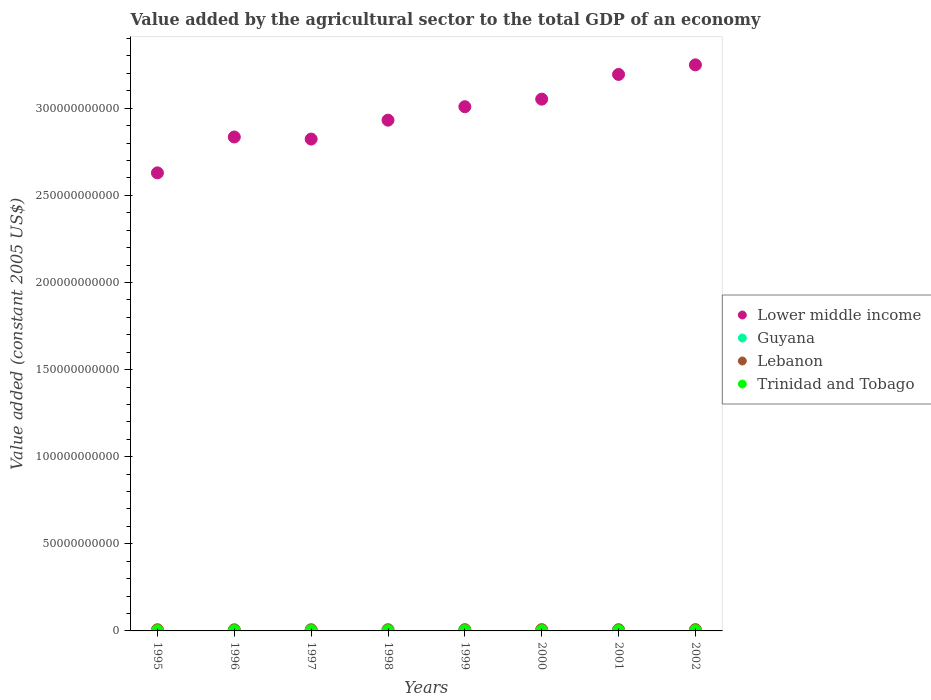How many different coloured dotlines are there?
Offer a very short reply. 4. What is the value added by the agricultural sector in Lower middle income in 1998?
Provide a succinct answer. 2.93e+11. Across all years, what is the maximum value added by the agricultural sector in Trinidad and Tobago?
Your response must be concise. 1.47e+08. Across all years, what is the minimum value added by the agricultural sector in Lower middle income?
Offer a very short reply. 2.63e+11. What is the total value added by the agricultural sector in Lebanon in the graph?
Your answer should be very brief. 5.63e+09. What is the difference between the value added by the agricultural sector in Lower middle income in 1997 and that in 2001?
Offer a very short reply. -3.71e+1. What is the difference between the value added by the agricultural sector in Guyana in 2002 and the value added by the agricultural sector in Trinidad and Tobago in 1996?
Make the answer very short. 1.49e+08. What is the average value added by the agricultural sector in Guyana per year?
Your response must be concise. 2.52e+08. In the year 1996, what is the difference between the value added by the agricultural sector in Lower middle income and value added by the agricultural sector in Trinidad and Tobago?
Provide a short and direct response. 2.83e+11. What is the ratio of the value added by the agricultural sector in Guyana in 1999 to that in 2001?
Offer a very short reply. 1.06. Is the difference between the value added by the agricultural sector in Lower middle income in 1997 and 1998 greater than the difference between the value added by the agricultural sector in Trinidad and Tobago in 1997 and 1998?
Offer a terse response. No. What is the difference between the highest and the second highest value added by the agricultural sector in Guyana?
Keep it short and to the point. 7.50e+06. What is the difference between the highest and the lowest value added by the agricultural sector in Guyana?
Give a very brief answer. 4.24e+07. Does the value added by the agricultural sector in Guyana monotonically increase over the years?
Make the answer very short. No. Is the value added by the agricultural sector in Lower middle income strictly greater than the value added by the agricultural sector in Trinidad and Tobago over the years?
Give a very brief answer. Yes. What is the difference between two consecutive major ticks on the Y-axis?
Your answer should be compact. 5.00e+1. Does the graph contain any zero values?
Your response must be concise. No. Does the graph contain grids?
Your answer should be very brief. No. What is the title of the graph?
Your response must be concise. Value added by the agricultural sector to the total GDP of an economy. What is the label or title of the X-axis?
Provide a succinct answer. Years. What is the label or title of the Y-axis?
Offer a terse response. Value added (constant 2005 US$). What is the Value added (constant 2005 US$) of Lower middle income in 1995?
Give a very brief answer. 2.63e+11. What is the Value added (constant 2005 US$) of Guyana in 1995?
Offer a very short reply. 2.30e+08. What is the Value added (constant 2005 US$) of Lebanon in 1995?
Offer a terse response. 6.78e+08. What is the Value added (constant 2005 US$) in Trinidad and Tobago in 1995?
Provide a succinct answer. 1.08e+08. What is the Value added (constant 2005 US$) of Lower middle income in 1996?
Provide a short and direct response. 2.83e+11. What is the Value added (constant 2005 US$) in Guyana in 1996?
Offer a very short reply. 2.47e+08. What is the Value added (constant 2005 US$) of Lebanon in 1996?
Ensure brevity in your answer.  6.49e+08. What is the Value added (constant 2005 US$) of Trinidad and Tobago in 1996?
Offer a very short reply. 1.17e+08. What is the Value added (constant 2005 US$) in Lower middle income in 1997?
Give a very brief answer. 2.82e+11. What is the Value added (constant 2005 US$) in Guyana in 1997?
Offer a terse response. 2.57e+08. What is the Value added (constant 2005 US$) of Lebanon in 1997?
Make the answer very short. 6.87e+08. What is the Value added (constant 2005 US$) of Trinidad and Tobago in 1997?
Give a very brief answer. 1.20e+08. What is the Value added (constant 2005 US$) in Lower middle income in 1998?
Provide a short and direct response. 2.93e+11. What is the Value added (constant 2005 US$) of Guyana in 1998?
Offer a very short reply. 2.40e+08. What is the Value added (constant 2005 US$) in Lebanon in 1998?
Your answer should be very brief. 6.95e+08. What is the Value added (constant 2005 US$) in Trinidad and Tobago in 1998?
Offer a very short reply. 1.09e+08. What is the Value added (constant 2005 US$) of Lower middle income in 1999?
Your answer should be very brief. 3.01e+11. What is the Value added (constant 2005 US$) in Guyana in 1999?
Offer a terse response. 2.73e+08. What is the Value added (constant 2005 US$) of Lebanon in 1999?
Your answer should be compact. 7.24e+08. What is the Value added (constant 2005 US$) in Trinidad and Tobago in 1999?
Give a very brief answer. 1.27e+08. What is the Value added (constant 2005 US$) of Lower middle income in 2000?
Offer a terse response. 3.05e+11. What is the Value added (constant 2005 US$) of Guyana in 2000?
Your answer should be compact. 2.48e+08. What is the Value added (constant 2005 US$) of Lebanon in 2000?
Your answer should be compact. 7.39e+08. What is the Value added (constant 2005 US$) of Trinidad and Tobago in 2000?
Your response must be concise. 1.24e+08. What is the Value added (constant 2005 US$) in Lower middle income in 2001?
Give a very brief answer. 3.19e+11. What is the Value added (constant 2005 US$) in Guyana in 2001?
Keep it short and to the point. 2.56e+08. What is the Value added (constant 2005 US$) in Lebanon in 2001?
Make the answer very short. 7.18e+08. What is the Value added (constant 2005 US$) of Trinidad and Tobago in 2001?
Your answer should be compact. 1.35e+08. What is the Value added (constant 2005 US$) in Lower middle income in 2002?
Make the answer very short. 3.25e+11. What is the Value added (constant 2005 US$) in Guyana in 2002?
Provide a succinct answer. 2.65e+08. What is the Value added (constant 2005 US$) of Lebanon in 2002?
Your answer should be compact. 7.38e+08. What is the Value added (constant 2005 US$) in Trinidad and Tobago in 2002?
Your response must be concise. 1.47e+08. Across all years, what is the maximum Value added (constant 2005 US$) in Lower middle income?
Give a very brief answer. 3.25e+11. Across all years, what is the maximum Value added (constant 2005 US$) of Guyana?
Your answer should be very brief. 2.73e+08. Across all years, what is the maximum Value added (constant 2005 US$) of Lebanon?
Give a very brief answer. 7.39e+08. Across all years, what is the maximum Value added (constant 2005 US$) of Trinidad and Tobago?
Ensure brevity in your answer.  1.47e+08. Across all years, what is the minimum Value added (constant 2005 US$) in Lower middle income?
Your response must be concise. 2.63e+11. Across all years, what is the minimum Value added (constant 2005 US$) in Guyana?
Ensure brevity in your answer.  2.30e+08. Across all years, what is the minimum Value added (constant 2005 US$) in Lebanon?
Your answer should be compact. 6.49e+08. Across all years, what is the minimum Value added (constant 2005 US$) of Trinidad and Tobago?
Provide a short and direct response. 1.08e+08. What is the total Value added (constant 2005 US$) of Lower middle income in the graph?
Offer a terse response. 2.37e+12. What is the total Value added (constant 2005 US$) in Guyana in the graph?
Your answer should be compact. 2.02e+09. What is the total Value added (constant 2005 US$) of Lebanon in the graph?
Make the answer very short. 5.63e+09. What is the total Value added (constant 2005 US$) of Trinidad and Tobago in the graph?
Your response must be concise. 9.87e+08. What is the difference between the Value added (constant 2005 US$) in Lower middle income in 1995 and that in 1996?
Ensure brevity in your answer.  -2.06e+1. What is the difference between the Value added (constant 2005 US$) in Guyana in 1995 and that in 1996?
Offer a terse response. -1.70e+07. What is the difference between the Value added (constant 2005 US$) in Lebanon in 1995 and that in 1996?
Give a very brief answer. 2.94e+07. What is the difference between the Value added (constant 2005 US$) in Trinidad and Tobago in 1995 and that in 1996?
Make the answer very short. -8.18e+06. What is the difference between the Value added (constant 2005 US$) of Lower middle income in 1995 and that in 1997?
Keep it short and to the point. -1.94e+1. What is the difference between the Value added (constant 2005 US$) of Guyana in 1995 and that in 1997?
Your answer should be compact. -2.67e+07. What is the difference between the Value added (constant 2005 US$) of Lebanon in 1995 and that in 1997?
Offer a very short reply. -9.33e+06. What is the difference between the Value added (constant 2005 US$) in Trinidad and Tobago in 1995 and that in 1997?
Your answer should be compact. -1.18e+07. What is the difference between the Value added (constant 2005 US$) in Lower middle income in 1995 and that in 1998?
Give a very brief answer. -3.03e+1. What is the difference between the Value added (constant 2005 US$) of Guyana in 1995 and that in 1998?
Make the answer very short. -1.01e+07. What is the difference between the Value added (constant 2005 US$) of Lebanon in 1995 and that in 1998?
Give a very brief answer. -1.69e+07. What is the difference between the Value added (constant 2005 US$) in Trinidad and Tobago in 1995 and that in 1998?
Make the answer very short. -5.92e+05. What is the difference between the Value added (constant 2005 US$) of Lower middle income in 1995 and that in 1999?
Your answer should be compact. -3.80e+1. What is the difference between the Value added (constant 2005 US$) of Guyana in 1995 and that in 1999?
Offer a very short reply. -4.24e+07. What is the difference between the Value added (constant 2005 US$) of Lebanon in 1995 and that in 1999?
Your response must be concise. -4.61e+07. What is the difference between the Value added (constant 2005 US$) of Trinidad and Tobago in 1995 and that in 1999?
Offer a terse response. -1.88e+07. What is the difference between the Value added (constant 2005 US$) in Lower middle income in 1995 and that in 2000?
Your response must be concise. -4.23e+1. What is the difference between the Value added (constant 2005 US$) of Guyana in 1995 and that in 2000?
Ensure brevity in your answer.  -1.75e+07. What is the difference between the Value added (constant 2005 US$) in Lebanon in 1995 and that in 2000?
Provide a short and direct response. -6.13e+07. What is the difference between the Value added (constant 2005 US$) in Trinidad and Tobago in 1995 and that in 2000?
Your answer should be very brief. -1.57e+07. What is the difference between the Value added (constant 2005 US$) in Lower middle income in 1995 and that in 2001?
Ensure brevity in your answer.  -5.65e+1. What is the difference between the Value added (constant 2005 US$) in Guyana in 1995 and that in 2001?
Offer a terse response. -2.59e+07. What is the difference between the Value added (constant 2005 US$) in Lebanon in 1995 and that in 2001?
Offer a terse response. -3.98e+07. What is the difference between the Value added (constant 2005 US$) in Trinidad and Tobago in 1995 and that in 2001?
Ensure brevity in your answer.  -2.65e+07. What is the difference between the Value added (constant 2005 US$) of Lower middle income in 1995 and that in 2002?
Give a very brief answer. -6.20e+1. What is the difference between the Value added (constant 2005 US$) of Guyana in 1995 and that in 2002?
Provide a short and direct response. -3.49e+07. What is the difference between the Value added (constant 2005 US$) in Lebanon in 1995 and that in 2002?
Provide a succinct answer. -5.99e+07. What is the difference between the Value added (constant 2005 US$) of Trinidad and Tobago in 1995 and that in 2002?
Provide a succinct answer. -3.83e+07. What is the difference between the Value added (constant 2005 US$) in Lower middle income in 1996 and that in 1997?
Make the answer very short. 1.19e+09. What is the difference between the Value added (constant 2005 US$) in Guyana in 1996 and that in 1997?
Provide a short and direct response. -9.79e+06. What is the difference between the Value added (constant 2005 US$) in Lebanon in 1996 and that in 1997?
Your response must be concise. -3.87e+07. What is the difference between the Value added (constant 2005 US$) of Trinidad and Tobago in 1996 and that in 1997?
Provide a short and direct response. -3.61e+06. What is the difference between the Value added (constant 2005 US$) of Lower middle income in 1996 and that in 1998?
Ensure brevity in your answer.  -9.66e+09. What is the difference between the Value added (constant 2005 US$) of Guyana in 1996 and that in 1998?
Make the answer very short. 6.85e+06. What is the difference between the Value added (constant 2005 US$) in Lebanon in 1996 and that in 1998?
Provide a succinct answer. -4.63e+07. What is the difference between the Value added (constant 2005 US$) in Trinidad and Tobago in 1996 and that in 1998?
Your response must be concise. 7.58e+06. What is the difference between the Value added (constant 2005 US$) of Lower middle income in 1996 and that in 1999?
Keep it short and to the point. -1.74e+1. What is the difference between the Value added (constant 2005 US$) of Guyana in 1996 and that in 1999?
Your response must be concise. -2.54e+07. What is the difference between the Value added (constant 2005 US$) in Lebanon in 1996 and that in 1999?
Your response must be concise. -7.54e+07. What is the difference between the Value added (constant 2005 US$) in Trinidad and Tobago in 1996 and that in 1999?
Your answer should be compact. -1.06e+07. What is the difference between the Value added (constant 2005 US$) in Lower middle income in 1996 and that in 2000?
Offer a terse response. -2.17e+1. What is the difference between the Value added (constant 2005 US$) of Guyana in 1996 and that in 2000?
Your answer should be very brief. -4.89e+05. What is the difference between the Value added (constant 2005 US$) of Lebanon in 1996 and that in 2000?
Offer a terse response. -9.06e+07. What is the difference between the Value added (constant 2005 US$) in Trinidad and Tobago in 1996 and that in 2000?
Ensure brevity in your answer.  -7.57e+06. What is the difference between the Value added (constant 2005 US$) of Lower middle income in 1996 and that in 2001?
Keep it short and to the point. -3.59e+1. What is the difference between the Value added (constant 2005 US$) of Guyana in 1996 and that in 2001?
Keep it short and to the point. -8.97e+06. What is the difference between the Value added (constant 2005 US$) in Lebanon in 1996 and that in 2001?
Your answer should be compact. -6.92e+07. What is the difference between the Value added (constant 2005 US$) in Trinidad and Tobago in 1996 and that in 2001?
Ensure brevity in your answer.  -1.83e+07. What is the difference between the Value added (constant 2005 US$) in Lower middle income in 1996 and that in 2002?
Offer a very short reply. -4.14e+1. What is the difference between the Value added (constant 2005 US$) of Guyana in 1996 and that in 2002?
Ensure brevity in your answer.  -1.79e+07. What is the difference between the Value added (constant 2005 US$) of Lebanon in 1996 and that in 2002?
Offer a terse response. -8.93e+07. What is the difference between the Value added (constant 2005 US$) of Trinidad and Tobago in 1996 and that in 2002?
Offer a terse response. -3.01e+07. What is the difference between the Value added (constant 2005 US$) in Lower middle income in 1997 and that in 1998?
Your answer should be very brief. -1.08e+1. What is the difference between the Value added (constant 2005 US$) of Guyana in 1997 and that in 1998?
Provide a short and direct response. 1.66e+07. What is the difference between the Value added (constant 2005 US$) in Lebanon in 1997 and that in 1998?
Offer a very short reply. -7.56e+06. What is the difference between the Value added (constant 2005 US$) of Trinidad and Tobago in 1997 and that in 1998?
Provide a succinct answer. 1.12e+07. What is the difference between the Value added (constant 2005 US$) in Lower middle income in 1997 and that in 1999?
Make the answer very short. -1.86e+1. What is the difference between the Value added (constant 2005 US$) in Guyana in 1997 and that in 1999?
Your answer should be compact. -1.57e+07. What is the difference between the Value added (constant 2005 US$) in Lebanon in 1997 and that in 1999?
Make the answer very short. -3.68e+07. What is the difference between the Value added (constant 2005 US$) in Trinidad and Tobago in 1997 and that in 1999?
Make the answer very short. -6.97e+06. What is the difference between the Value added (constant 2005 US$) of Lower middle income in 1997 and that in 2000?
Your answer should be compact. -2.29e+1. What is the difference between the Value added (constant 2005 US$) in Guyana in 1997 and that in 2000?
Provide a succinct answer. 9.30e+06. What is the difference between the Value added (constant 2005 US$) of Lebanon in 1997 and that in 2000?
Offer a terse response. -5.20e+07. What is the difference between the Value added (constant 2005 US$) of Trinidad and Tobago in 1997 and that in 2000?
Ensure brevity in your answer.  -3.96e+06. What is the difference between the Value added (constant 2005 US$) in Lower middle income in 1997 and that in 2001?
Offer a terse response. -3.71e+1. What is the difference between the Value added (constant 2005 US$) of Guyana in 1997 and that in 2001?
Your response must be concise. 8.15e+05. What is the difference between the Value added (constant 2005 US$) in Lebanon in 1997 and that in 2001?
Offer a very short reply. -3.05e+07. What is the difference between the Value added (constant 2005 US$) of Trinidad and Tobago in 1997 and that in 2001?
Ensure brevity in your answer.  -1.47e+07. What is the difference between the Value added (constant 2005 US$) in Lower middle income in 1997 and that in 2002?
Make the answer very short. -4.26e+1. What is the difference between the Value added (constant 2005 US$) of Guyana in 1997 and that in 2002?
Offer a very short reply. -8.15e+06. What is the difference between the Value added (constant 2005 US$) of Lebanon in 1997 and that in 2002?
Your response must be concise. -5.06e+07. What is the difference between the Value added (constant 2005 US$) in Trinidad and Tobago in 1997 and that in 2002?
Your answer should be compact. -2.65e+07. What is the difference between the Value added (constant 2005 US$) of Lower middle income in 1998 and that in 1999?
Ensure brevity in your answer.  -7.72e+09. What is the difference between the Value added (constant 2005 US$) of Guyana in 1998 and that in 1999?
Ensure brevity in your answer.  -3.23e+07. What is the difference between the Value added (constant 2005 US$) in Lebanon in 1998 and that in 1999?
Your answer should be compact. -2.92e+07. What is the difference between the Value added (constant 2005 US$) in Trinidad and Tobago in 1998 and that in 1999?
Provide a short and direct response. -1.82e+07. What is the difference between the Value added (constant 2005 US$) in Lower middle income in 1998 and that in 2000?
Provide a succinct answer. -1.21e+1. What is the difference between the Value added (constant 2005 US$) in Guyana in 1998 and that in 2000?
Provide a succinct answer. -7.34e+06. What is the difference between the Value added (constant 2005 US$) in Lebanon in 1998 and that in 2000?
Keep it short and to the point. -4.44e+07. What is the difference between the Value added (constant 2005 US$) of Trinidad and Tobago in 1998 and that in 2000?
Give a very brief answer. -1.52e+07. What is the difference between the Value added (constant 2005 US$) in Lower middle income in 1998 and that in 2001?
Your answer should be compact. -2.62e+1. What is the difference between the Value added (constant 2005 US$) in Guyana in 1998 and that in 2001?
Give a very brief answer. -1.58e+07. What is the difference between the Value added (constant 2005 US$) of Lebanon in 1998 and that in 2001?
Your answer should be compact. -2.30e+07. What is the difference between the Value added (constant 2005 US$) in Trinidad and Tobago in 1998 and that in 2001?
Offer a terse response. -2.59e+07. What is the difference between the Value added (constant 2005 US$) of Lower middle income in 1998 and that in 2002?
Make the answer very short. -3.17e+1. What is the difference between the Value added (constant 2005 US$) of Guyana in 1998 and that in 2002?
Provide a succinct answer. -2.48e+07. What is the difference between the Value added (constant 2005 US$) of Lebanon in 1998 and that in 2002?
Your answer should be very brief. -4.31e+07. What is the difference between the Value added (constant 2005 US$) in Trinidad and Tobago in 1998 and that in 2002?
Make the answer very short. -3.77e+07. What is the difference between the Value added (constant 2005 US$) in Lower middle income in 1999 and that in 2000?
Provide a succinct answer. -4.34e+09. What is the difference between the Value added (constant 2005 US$) of Guyana in 1999 and that in 2000?
Offer a terse response. 2.50e+07. What is the difference between the Value added (constant 2005 US$) of Lebanon in 1999 and that in 2000?
Make the answer very short. -1.52e+07. What is the difference between the Value added (constant 2005 US$) of Trinidad and Tobago in 1999 and that in 2000?
Your answer should be very brief. 3.01e+06. What is the difference between the Value added (constant 2005 US$) of Lower middle income in 1999 and that in 2001?
Ensure brevity in your answer.  -1.85e+1. What is the difference between the Value added (constant 2005 US$) of Guyana in 1999 and that in 2001?
Your response must be concise. 1.65e+07. What is the difference between the Value added (constant 2005 US$) in Lebanon in 1999 and that in 2001?
Provide a short and direct response. 6.23e+06. What is the difference between the Value added (constant 2005 US$) in Trinidad and Tobago in 1999 and that in 2001?
Your answer should be compact. -7.77e+06. What is the difference between the Value added (constant 2005 US$) in Lower middle income in 1999 and that in 2002?
Your answer should be compact. -2.40e+1. What is the difference between the Value added (constant 2005 US$) in Guyana in 1999 and that in 2002?
Give a very brief answer. 7.50e+06. What is the difference between the Value added (constant 2005 US$) of Lebanon in 1999 and that in 2002?
Provide a succinct answer. -1.39e+07. What is the difference between the Value added (constant 2005 US$) of Trinidad and Tobago in 1999 and that in 2002?
Ensure brevity in your answer.  -1.95e+07. What is the difference between the Value added (constant 2005 US$) of Lower middle income in 2000 and that in 2001?
Provide a succinct answer. -1.42e+1. What is the difference between the Value added (constant 2005 US$) of Guyana in 2000 and that in 2001?
Make the answer very short. -8.48e+06. What is the difference between the Value added (constant 2005 US$) of Lebanon in 2000 and that in 2001?
Your answer should be very brief. 2.14e+07. What is the difference between the Value added (constant 2005 US$) in Trinidad and Tobago in 2000 and that in 2001?
Provide a succinct answer. -1.08e+07. What is the difference between the Value added (constant 2005 US$) in Lower middle income in 2000 and that in 2002?
Offer a very short reply. -1.97e+1. What is the difference between the Value added (constant 2005 US$) of Guyana in 2000 and that in 2002?
Your response must be concise. -1.75e+07. What is the difference between the Value added (constant 2005 US$) in Lebanon in 2000 and that in 2002?
Your response must be concise. 1.34e+06. What is the difference between the Value added (constant 2005 US$) of Trinidad and Tobago in 2000 and that in 2002?
Provide a succinct answer. -2.25e+07. What is the difference between the Value added (constant 2005 US$) of Lower middle income in 2001 and that in 2002?
Ensure brevity in your answer.  -5.49e+09. What is the difference between the Value added (constant 2005 US$) of Guyana in 2001 and that in 2002?
Provide a short and direct response. -8.97e+06. What is the difference between the Value added (constant 2005 US$) of Lebanon in 2001 and that in 2002?
Provide a short and direct response. -2.01e+07. What is the difference between the Value added (constant 2005 US$) of Trinidad and Tobago in 2001 and that in 2002?
Your answer should be compact. -1.18e+07. What is the difference between the Value added (constant 2005 US$) in Lower middle income in 1995 and the Value added (constant 2005 US$) in Guyana in 1996?
Ensure brevity in your answer.  2.63e+11. What is the difference between the Value added (constant 2005 US$) in Lower middle income in 1995 and the Value added (constant 2005 US$) in Lebanon in 1996?
Offer a terse response. 2.62e+11. What is the difference between the Value added (constant 2005 US$) of Lower middle income in 1995 and the Value added (constant 2005 US$) of Trinidad and Tobago in 1996?
Make the answer very short. 2.63e+11. What is the difference between the Value added (constant 2005 US$) of Guyana in 1995 and the Value added (constant 2005 US$) of Lebanon in 1996?
Ensure brevity in your answer.  -4.18e+08. What is the difference between the Value added (constant 2005 US$) in Guyana in 1995 and the Value added (constant 2005 US$) in Trinidad and Tobago in 1996?
Keep it short and to the point. 1.14e+08. What is the difference between the Value added (constant 2005 US$) of Lebanon in 1995 and the Value added (constant 2005 US$) of Trinidad and Tobago in 1996?
Offer a very short reply. 5.61e+08. What is the difference between the Value added (constant 2005 US$) in Lower middle income in 1995 and the Value added (constant 2005 US$) in Guyana in 1997?
Your response must be concise. 2.63e+11. What is the difference between the Value added (constant 2005 US$) in Lower middle income in 1995 and the Value added (constant 2005 US$) in Lebanon in 1997?
Provide a succinct answer. 2.62e+11. What is the difference between the Value added (constant 2005 US$) in Lower middle income in 1995 and the Value added (constant 2005 US$) in Trinidad and Tobago in 1997?
Provide a succinct answer. 2.63e+11. What is the difference between the Value added (constant 2005 US$) of Guyana in 1995 and the Value added (constant 2005 US$) of Lebanon in 1997?
Provide a succinct answer. -4.57e+08. What is the difference between the Value added (constant 2005 US$) in Guyana in 1995 and the Value added (constant 2005 US$) in Trinidad and Tobago in 1997?
Your answer should be very brief. 1.10e+08. What is the difference between the Value added (constant 2005 US$) in Lebanon in 1995 and the Value added (constant 2005 US$) in Trinidad and Tobago in 1997?
Ensure brevity in your answer.  5.58e+08. What is the difference between the Value added (constant 2005 US$) in Lower middle income in 1995 and the Value added (constant 2005 US$) in Guyana in 1998?
Your answer should be compact. 2.63e+11. What is the difference between the Value added (constant 2005 US$) of Lower middle income in 1995 and the Value added (constant 2005 US$) of Lebanon in 1998?
Ensure brevity in your answer.  2.62e+11. What is the difference between the Value added (constant 2005 US$) in Lower middle income in 1995 and the Value added (constant 2005 US$) in Trinidad and Tobago in 1998?
Your answer should be compact. 2.63e+11. What is the difference between the Value added (constant 2005 US$) of Guyana in 1995 and the Value added (constant 2005 US$) of Lebanon in 1998?
Your response must be concise. -4.65e+08. What is the difference between the Value added (constant 2005 US$) of Guyana in 1995 and the Value added (constant 2005 US$) of Trinidad and Tobago in 1998?
Provide a short and direct response. 1.21e+08. What is the difference between the Value added (constant 2005 US$) in Lebanon in 1995 and the Value added (constant 2005 US$) in Trinidad and Tobago in 1998?
Make the answer very short. 5.69e+08. What is the difference between the Value added (constant 2005 US$) of Lower middle income in 1995 and the Value added (constant 2005 US$) of Guyana in 1999?
Provide a succinct answer. 2.63e+11. What is the difference between the Value added (constant 2005 US$) of Lower middle income in 1995 and the Value added (constant 2005 US$) of Lebanon in 1999?
Give a very brief answer. 2.62e+11. What is the difference between the Value added (constant 2005 US$) of Lower middle income in 1995 and the Value added (constant 2005 US$) of Trinidad and Tobago in 1999?
Ensure brevity in your answer.  2.63e+11. What is the difference between the Value added (constant 2005 US$) in Guyana in 1995 and the Value added (constant 2005 US$) in Lebanon in 1999?
Your answer should be very brief. -4.94e+08. What is the difference between the Value added (constant 2005 US$) of Guyana in 1995 and the Value added (constant 2005 US$) of Trinidad and Tobago in 1999?
Offer a terse response. 1.03e+08. What is the difference between the Value added (constant 2005 US$) in Lebanon in 1995 and the Value added (constant 2005 US$) in Trinidad and Tobago in 1999?
Your answer should be very brief. 5.51e+08. What is the difference between the Value added (constant 2005 US$) of Lower middle income in 1995 and the Value added (constant 2005 US$) of Guyana in 2000?
Offer a very short reply. 2.63e+11. What is the difference between the Value added (constant 2005 US$) in Lower middle income in 1995 and the Value added (constant 2005 US$) in Lebanon in 2000?
Offer a very short reply. 2.62e+11. What is the difference between the Value added (constant 2005 US$) in Lower middle income in 1995 and the Value added (constant 2005 US$) in Trinidad and Tobago in 2000?
Ensure brevity in your answer.  2.63e+11. What is the difference between the Value added (constant 2005 US$) of Guyana in 1995 and the Value added (constant 2005 US$) of Lebanon in 2000?
Offer a terse response. -5.09e+08. What is the difference between the Value added (constant 2005 US$) in Guyana in 1995 and the Value added (constant 2005 US$) in Trinidad and Tobago in 2000?
Ensure brevity in your answer.  1.06e+08. What is the difference between the Value added (constant 2005 US$) in Lebanon in 1995 and the Value added (constant 2005 US$) in Trinidad and Tobago in 2000?
Your response must be concise. 5.54e+08. What is the difference between the Value added (constant 2005 US$) of Lower middle income in 1995 and the Value added (constant 2005 US$) of Guyana in 2001?
Your answer should be very brief. 2.63e+11. What is the difference between the Value added (constant 2005 US$) of Lower middle income in 1995 and the Value added (constant 2005 US$) of Lebanon in 2001?
Your answer should be very brief. 2.62e+11. What is the difference between the Value added (constant 2005 US$) of Lower middle income in 1995 and the Value added (constant 2005 US$) of Trinidad and Tobago in 2001?
Keep it short and to the point. 2.63e+11. What is the difference between the Value added (constant 2005 US$) in Guyana in 1995 and the Value added (constant 2005 US$) in Lebanon in 2001?
Give a very brief answer. -4.88e+08. What is the difference between the Value added (constant 2005 US$) in Guyana in 1995 and the Value added (constant 2005 US$) in Trinidad and Tobago in 2001?
Your response must be concise. 9.53e+07. What is the difference between the Value added (constant 2005 US$) of Lebanon in 1995 and the Value added (constant 2005 US$) of Trinidad and Tobago in 2001?
Ensure brevity in your answer.  5.43e+08. What is the difference between the Value added (constant 2005 US$) of Lower middle income in 1995 and the Value added (constant 2005 US$) of Guyana in 2002?
Your answer should be very brief. 2.63e+11. What is the difference between the Value added (constant 2005 US$) of Lower middle income in 1995 and the Value added (constant 2005 US$) of Lebanon in 2002?
Provide a succinct answer. 2.62e+11. What is the difference between the Value added (constant 2005 US$) of Lower middle income in 1995 and the Value added (constant 2005 US$) of Trinidad and Tobago in 2002?
Make the answer very short. 2.63e+11. What is the difference between the Value added (constant 2005 US$) in Guyana in 1995 and the Value added (constant 2005 US$) in Lebanon in 2002?
Keep it short and to the point. -5.08e+08. What is the difference between the Value added (constant 2005 US$) in Guyana in 1995 and the Value added (constant 2005 US$) in Trinidad and Tobago in 2002?
Offer a terse response. 8.36e+07. What is the difference between the Value added (constant 2005 US$) in Lebanon in 1995 and the Value added (constant 2005 US$) in Trinidad and Tobago in 2002?
Offer a terse response. 5.31e+08. What is the difference between the Value added (constant 2005 US$) in Lower middle income in 1996 and the Value added (constant 2005 US$) in Guyana in 1997?
Your response must be concise. 2.83e+11. What is the difference between the Value added (constant 2005 US$) of Lower middle income in 1996 and the Value added (constant 2005 US$) of Lebanon in 1997?
Offer a terse response. 2.83e+11. What is the difference between the Value added (constant 2005 US$) in Lower middle income in 1996 and the Value added (constant 2005 US$) in Trinidad and Tobago in 1997?
Your answer should be compact. 2.83e+11. What is the difference between the Value added (constant 2005 US$) of Guyana in 1996 and the Value added (constant 2005 US$) of Lebanon in 1997?
Your answer should be compact. -4.40e+08. What is the difference between the Value added (constant 2005 US$) in Guyana in 1996 and the Value added (constant 2005 US$) in Trinidad and Tobago in 1997?
Offer a terse response. 1.27e+08. What is the difference between the Value added (constant 2005 US$) of Lebanon in 1996 and the Value added (constant 2005 US$) of Trinidad and Tobago in 1997?
Keep it short and to the point. 5.29e+08. What is the difference between the Value added (constant 2005 US$) of Lower middle income in 1996 and the Value added (constant 2005 US$) of Guyana in 1998?
Your response must be concise. 2.83e+11. What is the difference between the Value added (constant 2005 US$) in Lower middle income in 1996 and the Value added (constant 2005 US$) in Lebanon in 1998?
Provide a short and direct response. 2.83e+11. What is the difference between the Value added (constant 2005 US$) of Lower middle income in 1996 and the Value added (constant 2005 US$) of Trinidad and Tobago in 1998?
Offer a very short reply. 2.83e+11. What is the difference between the Value added (constant 2005 US$) of Guyana in 1996 and the Value added (constant 2005 US$) of Lebanon in 1998?
Give a very brief answer. -4.48e+08. What is the difference between the Value added (constant 2005 US$) of Guyana in 1996 and the Value added (constant 2005 US$) of Trinidad and Tobago in 1998?
Provide a succinct answer. 1.38e+08. What is the difference between the Value added (constant 2005 US$) of Lebanon in 1996 and the Value added (constant 2005 US$) of Trinidad and Tobago in 1998?
Your response must be concise. 5.40e+08. What is the difference between the Value added (constant 2005 US$) of Lower middle income in 1996 and the Value added (constant 2005 US$) of Guyana in 1999?
Give a very brief answer. 2.83e+11. What is the difference between the Value added (constant 2005 US$) in Lower middle income in 1996 and the Value added (constant 2005 US$) in Lebanon in 1999?
Make the answer very short. 2.83e+11. What is the difference between the Value added (constant 2005 US$) in Lower middle income in 1996 and the Value added (constant 2005 US$) in Trinidad and Tobago in 1999?
Give a very brief answer. 2.83e+11. What is the difference between the Value added (constant 2005 US$) in Guyana in 1996 and the Value added (constant 2005 US$) in Lebanon in 1999?
Provide a short and direct response. -4.77e+08. What is the difference between the Value added (constant 2005 US$) in Guyana in 1996 and the Value added (constant 2005 US$) in Trinidad and Tobago in 1999?
Your response must be concise. 1.20e+08. What is the difference between the Value added (constant 2005 US$) of Lebanon in 1996 and the Value added (constant 2005 US$) of Trinidad and Tobago in 1999?
Your answer should be very brief. 5.22e+08. What is the difference between the Value added (constant 2005 US$) in Lower middle income in 1996 and the Value added (constant 2005 US$) in Guyana in 2000?
Your answer should be compact. 2.83e+11. What is the difference between the Value added (constant 2005 US$) in Lower middle income in 1996 and the Value added (constant 2005 US$) in Lebanon in 2000?
Keep it short and to the point. 2.83e+11. What is the difference between the Value added (constant 2005 US$) of Lower middle income in 1996 and the Value added (constant 2005 US$) of Trinidad and Tobago in 2000?
Provide a succinct answer. 2.83e+11. What is the difference between the Value added (constant 2005 US$) of Guyana in 1996 and the Value added (constant 2005 US$) of Lebanon in 2000?
Your response must be concise. -4.92e+08. What is the difference between the Value added (constant 2005 US$) in Guyana in 1996 and the Value added (constant 2005 US$) in Trinidad and Tobago in 2000?
Your answer should be very brief. 1.23e+08. What is the difference between the Value added (constant 2005 US$) of Lebanon in 1996 and the Value added (constant 2005 US$) of Trinidad and Tobago in 2000?
Make the answer very short. 5.25e+08. What is the difference between the Value added (constant 2005 US$) of Lower middle income in 1996 and the Value added (constant 2005 US$) of Guyana in 2001?
Make the answer very short. 2.83e+11. What is the difference between the Value added (constant 2005 US$) of Lower middle income in 1996 and the Value added (constant 2005 US$) of Lebanon in 2001?
Your response must be concise. 2.83e+11. What is the difference between the Value added (constant 2005 US$) in Lower middle income in 1996 and the Value added (constant 2005 US$) in Trinidad and Tobago in 2001?
Provide a short and direct response. 2.83e+11. What is the difference between the Value added (constant 2005 US$) in Guyana in 1996 and the Value added (constant 2005 US$) in Lebanon in 2001?
Provide a short and direct response. -4.71e+08. What is the difference between the Value added (constant 2005 US$) of Guyana in 1996 and the Value added (constant 2005 US$) of Trinidad and Tobago in 2001?
Offer a terse response. 1.12e+08. What is the difference between the Value added (constant 2005 US$) of Lebanon in 1996 and the Value added (constant 2005 US$) of Trinidad and Tobago in 2001?
Your response must be concise. 5.14e+08. What is the difference between the Value added (constant 2005 US$) in Lower middle income in 1996 and the Value added (constant 2005 US$) in Guyana in 2002?
Your answer should be very brief. 2.83e+11. What is the difference between the Value added (constant 2005 US$) of Lower middle income in 1996 and the Value added (constant 2005 US$) of Lebanon in 2002?
Offer a very short reply. 2.83e+11. What is the difference between the Value added (constant 2005 US$) of Lower middle income in 1996 and the Value added (constant 2005 US$) of Trinidad and Tobago in 2002?
Provide a succinct answer. 2.83e+11. What is the difference between the Value added (constant 2005 US$) of Guyana in 1996 and the Value added (constant 2005 US$) of Lebanon in 2002?
Give a very brief answer. -4.91e+08. What is the difference between the Value added (constant 2005 US$) in Guyana in 1996 and the Value added (constant 2005 US$) in Trinidad and Tobago in 2002?
Ensure brevity in your answer.  1.01e+08. What is the difference between the Value added (constant 2005 US$) of Lebanon in 1996 and the Value added (constant 2005 US$) of Trinidad and Tobago in 2002?
Your answer should be very brief. 5.02e+08. What is the difference between the Value added (constant 2005 US$) in Lower middle income in 1997 and the Value added (constant 2005 US$) in Guyana in 1998?
Make the answer very short. 2.82e+11. What is the difference between the Value added (constant 2005 US$) of Lower middle income in 1997 and the Value added (constant 2005 US$) of Lebanon in 1998?
Your answer should be very brief. 2.82e+11. What is the difference between the Value added (constant 2005 US$) of Lower middle income in 1997 and the Value added (constant 2005 US$) of Trinidad and Tobago in 1998?
Offer a terse response. 2.82e+11. What is the difference between the Value added (constant 2005 US$) in Guyana in 1997 and the Value added (constant 2005 US$) in Lebanon in 1998?
Offer a very short reply. -4.38e+08. What is the difference between the Value added (constant 2005 US$) of Guyana in 1997 and the Value added (constant 2005 US$) of Trinidad and Tobago in 1998?
Make the answer very short. 1.48e+08. What is the difference between the Value added (constant 2005 US$) in Lebanon in 1997 and the Value added (constant 2005 US$) in Trinidad and Tobago in 1998?
Offer a terse response. 5.78e+08. What is the difference between the Value added (constant 2005 US$) of Lower middle income in 1997 and the Value added (constant 2005 US$) of Guyana in 1999?
Give a very brief answer. 2.82e+11. What is the difference between the Value added (constant 2005 US$) of Lower middle income in 1997 and the Value added (constant 2005 US$) of Lebanon in 1999?
Make the answer very short. 2.82e+11. What is the difference between the Value added (constant 2005 US$) in Lower middle income in 1997 and the Value added (constant 2005 US$) in Trinidad and Tobago in 1999?
Your answer should be compact. 2.82e+11. What is the difference between the Value added (constant 2005 US$) in Guyana in 1997 and the Value added (constant 2005 US$) in Lebanon in 1999?
Offer a terse response. -4.67e+08. What is the difference between the Value added (constant 2005 US$) of Guyana in 1997 and the Value added (constant 2005 US$) of Trinidad and Tobago in 1999?
Give a very brief answer. 1.30e+08. What is the difference between the Value added (constant 2005 US$) in Lebanon in 1997 and the Value added (constant 2005 US$) in Trinidad and Tobago in 1999?
Offer a very short reply. 5.60e+08. What is the difference between the Value added (constant 2005 US$) in Lower middle income in 1997 and the Value added (constant 2005 US$) in Guyana in 2000?
Provide a short and direct response. 2.82e+11. What is the difference between the Value added (constant 2005 US$) in Lower middle income in 1997 and the Value added (constant 2005 US$) in Lebanon in 2000?
Keep it short and to the point. 2.82e+11. What is the difference between the Value added (constant 2005 US$) in Lower middle income in 1997 and the Value added (constant 2005 US$) in Trinidad and Tobago in 2000?
Ensure brevity in your answer.  2.82e+11. What is the difference between the Value added (constant 2005 US$) in Guyana in 1997 and the Value added (constant 2005 US$) in Lebanon in 2000?
Your response must be concise. -4.82e+08. What is the difference between the Value added (constant 2005 US$) of Guyana in 1997 and the Value added (constant 2005 US$) of Trinidad and Tobago in 2000?
Your response must be concise. 1.33e+08. What is the difference between the Value added (constant 2005 US$) of Lebanon in 1997 and the Value added (constant 2005 US$) of Trinidad and Tobago in 2000?
Your answer should be very brief. 5.63e+08. What is the difference between the Value added (constant 2005 US$) of Lower middle income in 1997 and the Value added (constant 2005 US$) of Guyana in 2001?
Give a very brief answer. 2.82e+11. What is the difference between the Value added (constant 2005 US$) in Lower middle income in 1997 and the Value added (constant 2005 US$) in Lebanon in 2001?
Provide a succinct answer. 2.82e+11. What is the difference between the Value added (constant 2005 US$) of Lower middle income in 1997 and the Value added (constant 2005 US$) of Trinidad and Tobago in 2001?
Give a very brief answer. 2.82e+11. What is the difference between the Value added (constant 2005 US$) in Guyana in 1997 and the Value added (constant 2005 US$) in Lebanon in 2001?
Keep it short and to the point. -4.61e+08. What is the difference between the Value added (constant 2005 US$) in Guyana in 1997 and the Value added (constant 2005 US$) in Trinidad and Tobago in 2001?
Offer a very short reply. 1.22e+08. What is the difference between the Value added (constant 2005 US$) in Lebanon in 1997 and the Value added (constant 2005 US$) in Trinidad and Tobago in 2001?
Offer a very short reply. 5.52e+08. What is the difference between the Value added (constant 2005 US$) of Lower middle income in 1997 and the Value added (constant 2005 US$) of Guyana in 2002?
Offer a very short reply. 2.82e+11. What is the difference between the Value added (constant 2005 US$) in Lower middle income in 1997 and the Value added (constant 2005 US$) in Lebanon in 2002?
Make the answer very short. 2.82e+11. What is the difference between the Value added (constant 2005 US$) of Lower middle income in 1997 and the Value added (constant 2005 US$) of Trinidad and Tobago in 2002?
Ensure brevity in your answer.  2.82e+11. What is the difference between the Value added (constant 2005 US$) of Guyana in 1997 and the Value added (constant 2005 US$) of Lebanon in 2002?
Provide a succinct answer. -4.81e+08. What is the difference between the Value added (constant 2005 US$) in Guyana in 1997 and the Value added (constant 2005 US$) in Trinidad and Tobago in 2002?
Provide a short and direct response. 1.10e+08. What is the difference between the Value added (constant 2005 US$) of Lebanon in 1997 and the Value added (constant 2005 US$) of Trinidad and Tobago in 2002?
Offer a terse response. 5.41e+08. What is the difference between the Value added (constant 2005 US$) in Lower middle income in 1998 and the Value added (constant 2005 US$) in Guyana in 1999?
Offer a very short reply. 2.93e+11. What is the difference between the Value added (constant 2005 US$) of Lower middle income in 1998 and the Value added (constant 2005 US$) of Lebanon in 1999?
Your answer should be compact. 2.92e+11. What is the difference between the Value added (constant 2005 US$) of Lower middle income in 1998 and the Value added (constant 2005 US$) of Trinidad and Tobago in 1999?
Your response must be concise. 2.93e+11. What is the difference between the Value added (constant 2005 US$) of Guyana in 1998 and the Value added (constant 2005 US$) of Lebanon in 1999?
Make the answer very short. -4.84e+08. What is the difference between the Value added (constant 2005 US$) of Guyana in 1998 and the Value added (constant 2005 US$) of Trinidad and Tobago in 1999?
Make the answer very short. 1.13e+08. What is the difference between the Value added (constant 2005 US$) in Lebanon in 1998 and the Value added (constant 2005 US$) in Trinidad and Tobago in 1999?
Your answer should be very brief. 5.68e+08. What is the difference between the Value added (constant 2005 US$) of Lower middle income in 1998 and the Value added (constant 2005 US$) of Guyana in 2000?
Provide a succinct answer. 2.93e+11. What is the difference between the Value added (constant 2005 US$) in Lower middle income in 1998 and the Value added (constant 2005 US$) in Lebanon in 2000?
Ensure brevity in your answer.  2.92e+11. What is the difference between the Value added (constant 2005 US$) of Lower middle income in 1998 and the Value added (constant 2005 US$) of Trinidad and Tobago in 2000?
Offer a very short reply. 2.93e+11. What is the difference between the Value added (constant 2005 US$) in Guyana in 1998 and the Value added (constant 2005 US$) in Lebanon in 2000?
Offer a very short reply. -4.99e+08. What is the difference between the Value added (constant 2005 US$) of Guyana in 1998 and the Value added (constant 2005 US$) of Trinidad and Tobago in 2000?
Provide a succinct answer. 1.16e+08. What is the difference between the Value added (constant 2005 US$) in Lebanon in 1998 and the Value added (constant 2005 US$) in Trinidad and Tobago in 2000?
Make the answer very short. 5.71e+08. What is the difference between the Value added (constant 2005 US$) of Lower middle income in 1998 and the Value added (constant 2005 US$) of Guyana in 2001?
Give a very brief answer. 2.93e+11. What is the difference between the Value added (constant 2005 US$) of Lower middle income in 1998 and the Value added (constant 2005 US$) of Lebanon in 2001?
Offer a very short reply. 2.92e+11. What is the difference between the Value added (constant 2005 US$) of Lower middle income in 1998 and the Value added (constant 2005 US$) of Trinidad and Tobago in 2001?
Make the answer very short. 2.93e+11. What is the difference between the Value added (constant 2005 US$) of Guyana in 1998 and the Value added (constant 2005 US$) of Lebanon in 2001?
Your response must be concise. -4.78e+08. What is the difference between the Value added (constant 2005 US$) of Guyana in 1998 and the Value added (constant 2005 US$) of Trinidad and Tobago in 2001?
Offer a very short reply. 1.05e+08. What is the difference between the Value added (constant 2005 US$) of Lebanon in 1998 and the Value added (constant 2005 US$) of Trinidad and Tobago in 2001?
Provide a short and direct response. 5.60e+08. What is the difference between the Value added (constant 2005 US$) of Lower middle income in 1998 and the Value added (constant 2005 US$) of Guyana in 2002?
Offer a very short reply. 2.93e+11. What is the difference between the Value added (constant 2005 US$) in Lower middle income in 1998 and the Value added (constant 2005 US$) in Lebanon in 2002?
Your response must be concise. 2.92e+11. What is the difference between the Value added (constant 2005 US$) of Lower middle income in 1998 and the Value added (constant 2005 US$) of Trinidad and Tobago in 2002?
Ensure brevity in your answer.  2.93e+11. What is the difference between the Value added (constant 2005 US$) of Guyana in 1998 and the Value added (constant 2005 US$) of Lebanon in 2002?
Provide a succinct answer. -4.98e+08. What is the difference between the Value added (constant 2005 US$) of Guyana in 1998 and the Value added (constant 2005 US$) of Trinidad and Tobago in 2002?
Keep it short and to the point. 9.37e+07. What is the difference between the Value added (constant 2005 US$) of Lebanon in 1998 and the Value added (constant 2005 US$) of Trinidad and Tobago in 2002?
Keep it short and to the point. 5.48e+08. What is the difference between the Value added (constant 2005 US$) of Lower middle income in 1999 and the Value added (constant 2005 US$) of Guyana in 2000?
Keep it short and to the point. 3.01e+11. What is the difference between the Value added (constant 2005 US$) in Lower middle income in 1999 and the Value added (constant 2005 US$) in Lebanon in 2000?
Give a very brief answer. 3.00e+11. What is the difference between the Value added (constant 2005 US$) in Lower middle income in 1999 and the Value added (constant 2005 US$) in Trinidad and Tobago in 2000?
Your response must be concise. 3.01e+11. What is the difference between the Value added (constant 2005 US$) of Guyana in 1999 and the Value added (constant 2005 US$) of Lebanon in 2000?
Offer a very short reply. -4.67e+08. What is the difference between the Value added (constant 2005 US$) of Guyana in 1999 and the Value added (constant 2005 US$) of Trinidad and Tobago in 2000?
Provide a short and direct response. 1.48e+08. What is the difference between the Value added (constant 2005 US$) in Lebanon in 1999 and the Value added (constant 2005 US$) in Trinidad and Tobago in 2000?
Ensure brevity in your answer.  6.00e+08. What is the difference between the Value added (constant 2005 US$) in Lower middle income in 1999 and the Value added (constant 2005 US$) in Guyana in 2001?
Ensure brevity in your answer.  3.01e+11. What is the difference between the Value added (constant 2005 US$) of Lower middle income in 1999 and the Value added (constant 2005 US$) of Lebanon in 2001?
Your answer should be very brief. 3.00e+11. What is the difference between the Value added (constant 2005 US$) in Lower middle income in 1999 and the Value added (constant 2005 US$) in Trinidad and Tobago in 2001?
Provide a short and direct response. 3.01e+11. What is the difference between the Value added (constant 2005 US$) of Guyana in 1999 and the Value added (constant 2005 US$) of Lebanon in 2001?
Keep it short and to the point. -4.45e+08. What is the difference between the Value added (constant 2005 US$) of Guyana in 1999 and the Value added (constant 2005 US$) of Trinidad and Tobago in 2001?
Offer a very short reply. 1.38e+08. What is the difference between the Value added (constant 2005 US$) in Lebanon in 1999 and the Value added (constant 2005 US$) in Trinidad and Tobago in 2001?
Keep it short and to the point. 5.89e+08. What is the difference between the Value added (constant 2005 US$) of Lower middle income in 1999 and the Value added (constant 2005 US$) of Guyana in 2002?
Offer a very short reply. 3.01e+11. What is the difference between the Value added (constant 2005 US$) of Lower middle income in 1999 and the Value added (constant 2005 US$) of Lebanon in 2002?
Your answer should be compact. 3.00e+11. What is the difference between the Value added (constant 2005 US$) of Lower middle income in 1999 and the Value added (constant 2005 US$) of Trinidad and Tobago in 2002?
Give a very brief answer. 3.01e+11. What is the difference between the Value added (constant 2005 US$) in Guyana in 1999 and the Value added (constant 2005 US$) in Lebanon in 2002?
Ensure brevity in your answer.  -4.65e+08. What is the difference between the Value added (constant 2005 US$) in Guyana in 1999 and the Value added (constant 2005 US$) in Trinidad and Tobago in 2002?
Ensure brevity in your answer.  1.26e+08. What is the difference between the Value added (constant 2005 US$) in Lebanon in 1999 and the Value added (constant 2005 US$) in Trinidad and Tobago in 2002?
Ensure brevity in your answer.  5.77e+08. What is the difference between the Value added (constant 2005 US$) of Lower middle income in 2000 and the Value added (constant 2005 US$) of Guyana in 2001?
Offer a very short reply. 3.05e+11. What is the difference between the Value added (constant 2005 US$) in Lower middle income in 2000 and the Value added (constant 2005 US$) in Lebanon in 2001?
Make the answer very short. 3.05e+11. What is the difference between the Value added (constant 2005 US$) in Lower middle income in 2000 and the Value added (constant 2005 US$) in Trinidad and Tobago in 2001?
Offer a terse response. 3.05e+11. What is the difference between the Value added (constant 2005 US$) in Guyana in 2000 and the Value added (constant 2005 US$) in Lebanon in 2001?
Offer a very short reply. -4.70e+08. What is the difference between the Value added (constant 2005 US$) of Guyana in 2000 and the Value added (constant 2005 US$) of Trinidad and Tobago in 2001?
Your answer should be compact. 1.13e+08. What is the difference between the Value added (constant 2005 US$) in Lebanon in 2000 and the Value added (constant 2005 US$) in Trinidad and Tobago in 2001?
Ensure brevity in your answer.  6.04e+08. What is the difference between the Value added (constant 2005 US$) in Lower middle income in 2000 and the Value added (constant 2005 US$) in Guyana in 2002?
Your answer should be very brief. 3.05e+11. What is the difference between the Value added (constant 2005 US$) of Lower middle income in 2000 and the Value added (constant 2005 US$) of Lebanon in 2002?
Make the answer very short. 3.04e+11. What is the difference between the Value added (constant 2005 US$) of Lower middle income in 2000 and the Value added (constant 2005 US$) of Trinidad and Tobago in 2002?
Provide a short and direct response. 3.05e+11. What is the difference between the Value added (constant 2005 US$) in Guyana in 2000 and the Value added (constant 2005 US$) in Lebanon in 2002?
Provide a short and direct response. -4.90e+08. What is the difference between the Value added (constant 2005 US$) in Guyana in 2000 and the Value added (constant 2005 US$) in Trinidad and Tobago in 2002?
Keep it short and to the point. 1.01e+08. What is the difference between the Value added (constant 2005 US$) in Lebanon in 2000 and the Value added (constant 2005 US$) in Trinidad and Tobago in 2002?
Offer a terse response. 5.93e+08. What is the difference between the Value added (constant 2005 US$) of Lower middle income in 2001 and the Value added (constant 2005 US$) of Guyana in 2002?
Make the answer very short. 3.19e+11. What is the difference between the Value added (constant 2005 US$) in Lower middle income in 2001 and the Value added (constant 2005 US$) in Lebanon in 2002?
Make the answer very short. 3.19e+11. What is the difference between the Value added (constant 2005 US$) of Lower middle income in 2001 and the Value added (constant 2005 US$) of Trinidad and Tobago in 2002?
Your response must be concise. 3.19e+11. What is the difference between the Value added (constant 2005 US$) of Guyana in 2001 and the Value added (constant 2005 US$) of Lebanon in 2002?
Offer a terse response. -4.82e+08. What is the difference between the Value added (constant 2005 US$) in Guyana in 2001 and the Value added (constant 2005 US$) in Trinidad and Tobago in 2002?
Your answer should be compact. 1.09e+08. What is the difference between the Value added (constant 2005 US$) of Lebanon in 2001 and the Value added (constant 2005 US$) of Trinidad and Tobago in 2002?
Your response must be concise. 5.71e+08. What is the average Value added (constant 2005 US$) in Lower middle income per year?
Ensure brevity in your answer.  2.97e+11. What is the average Value added (constant 2005 US$) of Guyana per year?
Make the answer very short. 2.52e+08. What is the average Value added (constant 2005 US$) in Lebanon per year?
Give a very brief answer. 7.04e+08. What is the average Value added (constant 2005 US$) of Trinidad and Tobago per year?
Offer a very short reply. 1.23e+08. In the year 1995, what is the difference between the Value added (constant 2005 US$) of Lower middle income and Value added (constant 2005 US$) of Guyana?
Offer a very short reply. 2.63e+11. In the year 1995, what is the difference between the Value added (constant 2005 US$) of Lower middle income and Value added (constant 2005 US$) of Lebanon?
Offer a terse response. 2.62e+11. In the year 1995, what is the difference between the Value added (constant 2005 US$) of Lower middle income and Value added (constant 2005 US$) of Trinidad and Tobago?
Give a very brief answer. 2.63e+11. In the year 1995, what is the difference between the Value added (constant 2005 US$) of Guyana and Value added (constant 2005 US$) of Lebanon?
Keep it short and to the point. -4.48e+08. In the year 1995, what is the difference between the Value added (constant 2005 US$) of Guyana and Value added (constant 2005 US$) of Trinidad and Tobago?
Offer a very short reply. 1.22e+08. In the year 1995, what is the difference between the Value added (constant 2005 US$) in Lebanon and Value added (constant 2005 US$) in Trinidad and Tobago?
Your answer should be very brief. 5.70e+08. In the year 1996, what is the difference between the Value added (constant 2005 US$) of Lower middle income and Value added (constant 2005 US$) of Guyana?
Your answer should be very brief. 2.83e+11. In the year 1996, what is the difference between the Value added (constant 2005 US$) of Lower middle income and Value added (constant 2005 US$) of Lebanon?
Your response must be concise. 2.83e+11. In the year 1996, what is the difference between the Value added (constant 2005 US$) in Lower middle income and Value added (constant 2005 US$) in Trinidad and Tobago?
Keep it short and to the point. 2.83e+11. In the year 1996, what is the difference between the Value added (constant 2005 US$) of Guyana and Value added (constant 2005 US$) of Lebanon?
Make the answer very short. -4.01e+08. In the year 1996, what is the difference between the Value added (constant 2005 US$) of Guyana and Value added (constant 2005 US$) of Trinidad and Tobago?
Make the answer very short. 1.31e+08. In the year 1996, what is the difference between the Value added (constant 2005 US$) in Lebanon and Value added (constant 2005 US$) in Trinidad and Tobago?
Your answer should be compact. 5.32e+08. In the year 1997, what is the difference between the Value added (constant 2005 US$) of Lower middle income and Value added (constant 2005 US$) of Guyana?
Your answer should be compact. 2.82e+11. In the year 1997, what is the difference between the Value added (constant 2005 US$) of Lower middle income and Value added (constant 2005 US$) of Lebanon?
Your answer should be very brief. 2.82e+11. In the year 1997, what is the difference between the Value added (constant 2005 US$) in Lower middle income and Value added (constant 2005 US$) in Trinidad and Tobago?
Offer a terse response. 2.82e+11. In the year 1997, what is the difference between the Value added (constant 2005 US$) of Guyana and Value added (constant 2005 US$) of Lebanon?
Make the answer very short. -4.30e+08. In the year 1997, what is the difference between the Value added (constant 2005 US$) in Guyana and Value added (constant 2005 US$) in Trinidad and Tobago?
Keep it short and to the point. 1.37e+08. In the year 1997, what is the difference between the Value added (constant 2005 US$) of Lebanon and Value added (constant 2005 US$) of Trinidad and Tobago?
Offer a very short reply. 5.67e+08. In the year 1998, what is the difference between the Value added (constant 2005 US$) in Lower middle income and Value added (constant 2005 US$) in Guyana?
Keep it short and to the point. 2.93e+11. In the year 1998, what is the difference between the Value added (constant 2005 US$) in Lower middle income and Value added (constant 2005 US$) in Lebanon?
Your response must be concise. 2.92e+11. In the year 1998, what is the difference between the Value added (constant 2005 US$) in Lower middle income and Value added (constant 2005 US$) in Trinidad and Tobago?
Give a very brief answer. 2.93e+11. In the year 1998, what is the difference between the Value added (constant 2005 US$) of Guyana and Value added (constant 2005 US$) of Lebanon?
Give a very brief answer. -4.55e+08. In the year 1998, what is the difference between the Value added (constant 2005 US$) in Guyana and Value added (constant 2005 US$) in Trinidad and Tobago?
Your response must be concise. 1.31e+08. In the year 1998, what is the difference between the Value added (constant 2005 US$) of Lebanon and Value added (constant 2005 US$) of Trinidad and Tobago?
Provide a succinct answer. 5.86e+08. In the year 1999, what is the difference between the Value added (constant 2005 US$) in Lower middle income and Value added (constant 2005 US$) in Guyana?
Provide a short and direct response. 3.01e+11. In the year 1999, what is the difference between the Value added (constant 2005 US$) of Lower middle income and Value added (constant 2005 US$) of Lebanon?
Ensure brevity in your answer.  3.00e+11. In the year 1999, what is the difference between the Value added (constant 2005 US$) in Lower middle income and Value added (constant 2005 US$) in Trinidad and Tobago?
Keep it short and to the point. 3.01e+11. In the year 1999, what is the difference between the Value added (constant 2005 US$) of Guyana and Value added (constant 2005 US$) of Lebanon?
Offer a very short reply. -4.51e+08. In the year 1999, what is the difference between the Value added (constant 2005 US$) in Guyana and Value added (constant 2005 US$) in Trinidad and Tobago?
Your answer should be compact. 1.45e+08. In the year 1999, what is the difference between the Value added (constant 2005 US$) in Lebanon and Value added (constant 2005 US$) in Trinidad and Tobago?
Ensure brevity in your answer.  5.97e+08. In the year 2000, what is the difference between the Value added (constant 2005 US$) of Lower middle income and Value added (constant 2005 US$) of Guyana?
Offer a terse response. 3.05e+11. In the year 2000, what is the difference between the Value added (constant 2005 US$) of Lower middle income and Value added (constant 2005 US$) of Lebanon?
Make the answer very short. 3.04e+11. In the year 2000, what is the difference between the Value added (constant 2005 US$) in Lower middle income and Value added (constant 2005 US$) in Trinidad and Tobago?
Your answer should be very brief. 3.05e+11. In the year 2000, what is the difference between the Value added (constant 2005 US$) in Guyana and Value added (constant 2005 US$) in Lebanon?
Provide a short and direct response. -4.92e+08. In the year 2000, what is the difference between the Value added (constant 2005 US$) in Guyana and Value added (constant 2005 US$) in Trinidad and Tobago?
Keep it short and to the point. 1.24e+08. In the year 2000, what is the difference between the Value added (constant 2005 US$) of Lebanon and Value added (constant 2005 US$) of Trinidad and Tobago?
Your answer should be very brief. 6.15e+08. In the year 2001, what is the difference between the Value added (constant 2005 US$) of Lower middle income and Value added (constant 2005 US$) of Guyana?
Keep it short and to the point. 3.19e+11. In the year 2001, what is the difference between the Value added (constant 2005 US$) of Lower middle income and Value added (constant 2005 US$) of Lebanon?
Provide a succinct answer. 3.19e+11. In the year 2001, what is the difference between the Value added (constant 2005 US$) in Lower middle income and Value added (constant 2005 US$) in Trinidad and Tobago?
Your answer should be compact. 3.19e+11. In the year 2001, what is the difference between the Value added (constant 2005 US$) of Guyana and Value added (constant 2005 US$) of Lebanon?
Your answer should be compact. -4.62e+08. In the year 2001, what is the difference between the Value added (constant 2005 US$) in Guyana and Value added (constant 2005 US$) in Trinidad and Tobago?
Make the answer very short. 1.21e+08. In the year 2001, what is the difference between the Value added (constant 2005 US$) in Lebanon and Value added (constant 2005 US$) in Trinidad and Tobago?
Ensure brevity in your answer.  5.83e+08. In the year 2002, what is the difference between the Value added (constant 2005 US$) in Lower middle income and Value added (constant 2005 US$) in Guyana?
Provide a short and direct response. 3.25e+11. In the year 2002, what is the difference between the Value added (constant 2005 US$) of Lower middle income and Value added (constant 2005 US$) of Lebanon?
Offer a very short reply. 3.24e+11. In the year 2002, what is the difference between the Value added (constant 2005 US$) in Lower middle income and Value added (constant 2005 US$) in Trinidad and Tobago?
Your response must be concise. 3.25e+11. In the year 2002, what is the difference between the Value added (constant 2005 US$) of Guyana and Value added (constant 2005 US$) of Lebanon?
Ensure brevity in your answer.  -4.73e+08. In the year 2002, what is the difference between the Value added (constant 2005 US$) of Guyana and Value added (constant 2005 US$) of Trinidad and Tobago?
Give a very brief answer. 1.18e+08. In the year 2002, what is the difference between the Value added (constant 2005 US$) of Lebanon and Value added (constant 2005 US$) of Trinidad and Tobago?
Keep it short and to the point. 5.91e+08. What is the ratio of the Value added (constant 2005 US$) of Lower middle income in 1995 to that in 1996?
Give a very brief answer. 0.93. What is the ratio of the Value added (constant 2005 US$) in Guyana in 1995 to that in 1996?
Make the answer very short. 0.93. What is the ratio of the Value added (constant 2005 US$) of Lebanon in 1995 to that in 1996?
Your answer should be very brief. 1.05. What is the ratio of the Value added (constant 2005 US$) in Trinidad and Tobago in 1995 to that in 1996?
Keep it short and to the point. 0.93. What is the ratio of the Value added (constant 2005 US$) in Lower middle income in 1995 to that in 1997?
Give a very brief answer. 0.93. What is the ratio of the Value added (constant 2005 US$) in Guyana in 1995 to that in 1997?
Your answer should be compact. 0.9. What is the ratio of the Value added (constant 2005 US$) of Lebanon in 1995 to that in 1997?
Ensure brevity in your answer.  0.99. What is the ratio of the Value added (constant 2005 US$) in Trinidad and Tobago in 1995 to that in 1997?
Your response must be concise. 0.9. What is the ratio of the Value added (constant 2005 US$) of Lower middle income in 1995 to that in 1998?
Your answer should be compact. 0.9. What is the ratio of the Value added (constant 2005 US$) in Guyana in 1995 to that in 1998?
Give a very brief answer. 0.96. What is the ratio of the Value added (constant 2005 US$) of Lebanon in 1995 to that in 1998?
Your answer should be very brief. 0.98. What is the ratio of the Value added (constant 2005 US$) of Trinidad and Tobago in 1995 to that in 1998?
Ensure brevity in your answer.  0.99. What is the ratio of the Value added (constant 2005 US$) in Lower middle income in 1995 to that in 1999?
Keep it short and to the point. 0.87. What is the ratio of the Value added (constant 2005 US$) of Guyana in 1995 to that in 1999?
Provide a short and direct response. 0.84. What is the ratio of the Value added (constant 2005 US$) in Lebanon in 1995 to that in 1999?
Make the answer very short. 0.94. What is the ratio of the Value added (constant 2005 US$) in Trinidad and Tobago in 1995 to that in 1999?
Your answer should be compact. 0.85. What is the ratio of the Value added (constant 2005 US$) of Lower middle income in 1995 to that in 2000?
Offer a very short reply. 0.86. What is the ratio of the Value added (constant 2005 US$) of Guyana in 1995 to that in 2000?
Give a very brief answer. 0.93. What is the ratio of the Value added (constant 2005 US$) in Lebanon in 1995 to that in 2000?
Make the answer very short. 0.92. What is the ratio of the Value added (constant 2005 US$) of Trinidad and Tobago in 1995 to that in 2000?
Your answer should be compact. 0.87. What is the ratio of the Value added (constant 2005 US$) of Lower middle income in 1995 to that in 2001?
Provide a short and direct response. 0.82. What is the ratio of the Value added (constant 2005 US$) of Guyana in 1995 to that in 2001?
Your answer should be compact. 0.9. What is the ratio of the Value added (constant 2005 US$) of Lebanon in 1995 to that in 2001?
Your response must be concise. 0.94. What is the ratio of the Value added (constant 2005 US$) in Trinidad and Tobago in 1995 to that in 2001?
Your answer should be very brief. 0.8. What is the ratio of the Value added (constant 2005 US$) of Lower middle income in 1995 to that in 2002?
Provide a short and direct response. 0.81. What is the ratio of the Value added (constant 2005 US$) in Guyana in 1995 to that in 2002?
Ensure brevity in your answer.  0.87. What is the ratio of the Value added (constant 2005 US$) of Lebanon in 1995 to that in 2002?
Your answer should be compact. 0.92. What is the ratio of the Value added (constant 2005 US$) in Trinidad and Tobago in 1995 to that in 2002?
Provide a short and direct response. 0.74. What is the ratio of the Value added (constant 2005 US$) in Guyana in 1996 to that in 1997?
Offer a very short reply. 0.96. What is the ratio of the Value added (constant 2005 US$) of Lebanon in 1996 to that in 1997?
Give a very brief answer. 0.94. What is the ratio of the Value added (constant 2005 US$) of Trinidad and Tobago in 1996 to that in 1997?
Offer a very short reply. 0.97. What is the ratio of the Value added (constant 2005 US$) of Lower middle income in 1996 to that in 1998?
Offer a very short reply. 0.97. What is the ratio of the Value added (constant 2005 US$) of Guyana in 1996 to that in 1998?
Offer a terse response. 1.03. What is the ratio of the Value added (constant 2005 US$) in Lebanon in 1996 to that in 1998?
Make the answer very short. 0.93. What is the ratio of the Value added (constant 2005 US$) in Trinidad and Tobago in 1996 to that in 1998?
Give a very brief answer. 1.07. What is the ratio of the Value added (constant 2005 US$) of Lower middle income in 1996 to that in 1999?
Make the answer very short. 0.94. What is the ratio of the Value added (constant 2005 US$) of Guyana in 1996 to that in 1999?
Offer a terse response. 0.91. What is the ratio of the Value added (constant 2005 US$) of Lebanon in 1996 to that in 1999?
Your answer should be compact. 0.9. What is the ratio of the Value added (constant 2005 US$) of Trinidad and Tobago in 1996 to that in 1999?
Give a very brief answer. 0.92. What is the ratio of the Value added (constant 2005 US$) in Lower middle income in 1996 to that in 2000?
Ensure brevity in your answer.  0.93. What is the ratio of the Value added (constant 2005 US$) in Lebanon in 1996 to that in 2000?
Provide a short and direct response. 0.88. What is the ratio of the Value added (constant 2005 US$) in Trinidad and Tobago in 1996 to that in 2000?
Offer a very short reply. 0.94. What is the ratio of the Value added (constant 2005 US$) in Lower middle income in 1996 to that in 2001?
Keep it short and to the point. 0.89. What is the ratio of the Value added (constant 2005 US$) in Guyana in 1996 to that in 2001?
Your answer should be very brief. 0.96. What is the ratio of the Value added (constant 2005 US$) of Lebanon in 1996 to that in 2001?
Make the answer very short. 0.9. What is the ratio of the Value added (constant 2005 US$) in Trinidad and Tobago in 1996 to that in 2001?
Your answer should be very brief. 0.86. What is the ratio of the Value added (constant 2005 US$) in Lower middle income in 1996 to that in 2002?
Ensure brevity in your answer.  0.87. What is the ratio of the Value added (constant 2005 US$) of Guyana in 1996 to that in 2002?
Keep it short and to the point. 0.93. What is the ratio of the Value added (constant 2005 US$) in Lebanon in 1996 to that in 2002?
Your response must be concise. 0.88. What is the ratio of the Value added (constant 2005 US$) in Trinidad and Tobago in 1996 to that in 2002?
Provide a succinct answer. 0.79. What is the ratio of the Value added (constant 2005 US$) of Guyana in 1997 to that in 1998?
Offer a terse response. 1.07. What is the ratio of the Value added (constant 2005 US$) of Lebanon in 1997 to that in 1998?
Your answer should be very brief. 0.99. What is the ratio of the Value added (constant 2005 US$) in Trinidad and Tobago in 1997 to that in 1998?
Make the answer very short. 1.1. What is the ratio of the Value added (constant 2005 US$) of Lower middle income in 1997 to that in 1999?
Your answer should be very brief. 0.94. What is the ratio of the Value added (constant 2005 US$) in Guyana in 1997 to that in 1999?
Make the answer very short. 0.94. What is the ratio of the Value added (constant 2005 US$) of Lebanon in 1997 to that in 1999?
Your response must be concise. 0.95. What is the ratio of the Value added (constant 2005 US$) in Trinidad and Tobago in 1997 to that in 1999?
Your response must be concise. 0.95. What is the ratio of the Value added (constant 2005 US$) in Lower middle income in 1997 to that in 2000?
Provide a short and direct response. 0.92. What is the ratio of the Value added (constant 2005 US$) of Guyana in 1997 to that in 2000?
Ensure brevity in your answer.  1.04. What is the ratio of the Value added (constant 2005 US$) in Lebanon in 1997 to that in 2000?
Your response must be concise. 0.93. What is the ratio of the Value added (constant 2005 US$) of Trinidad and Tobago in 1997 to that in 2000?
Provide a short and direct response. 0.97. What is the ratio of the Value added (constant 2005 US$) in Lower middle income in 1997 to that in 2001?
Offer a very short reply. 0.88. What is the ratio of the Value added (constant 2005 US$) in Guyana in 1997 to that in 2001?
Your answer should be compact. 1. What is the ratio of the Value added (constant 2005 US$) in Lebanon in 1997 to that in 2001?
Your answer should be very brief. 0.96. What is the ratio of the Value added (constant 2005 US$) of Trinidad and Tobago in 1997 to that in 2001?
Make the answer very short. 0.89. What is the ratio of the Value added (constant 2005 US$) of Lower middle income in 1997 to that in 2002?
Your answer should be very brief. 0.87. What is the ratio of the Value added (constant 2005 US$) of Guyana in 1997 to that in 2002?
Your answer should be compact. 0.97. What is the ratio of the Value added (constant 2005 US$) of Lebanon in 1997 to that in 2002?
Your response must be concise. 0.93. What is the ratio of the Value added (constant 2005 US$) in Trinidad and Tobago in 1997 to that in 2002?
Give a very brief answer. 0.82. What is the ratio of the Value added (constant 2005 US$) of Lower middle income in 1998 to that in 1999?
Provide a succinct answer. 0.97. What is the ratio of the Value added (constant 2005 US$) in Guyana in 1998 to that in 1999?
Offer a terse response. 0.88. What is the ratio of the Value added (constant 2005 US$) in Lebanon in 1998 to that in 1999?
Offer a very short reply. 0.96. What is the ratio of the Value added (constant 2005 US$) of Trinidad and Tobago in 1998 to that in 1999?
Give a very brief answer. 0.86. What is the ratio of the Value added (constant 2005 US$) of Lower middle income in 1998 to that in 2000?
Ensure brevity in your answer.  0.96. What is the ratio of the Value added (constant 2005 US$) in Guyana in 1998 to that in 2000?
Offer a terse response. 0.97. What is the ratio of the Value added (constant 2005 US$) in Lebanon in 1998 to that in 2000?
Offer a terse response. 0.94. What is the ratio of the Value added (constant 2005 US$) in Trinidad and Tobago in 1998 to that in 2000?
Make the answer very short. 0.88. What is the ratio of the Value added (constant 2005 US$) in Lower middle income in 1998 to that in 2001?
Ensure brevity in your answer.  0.92. What is the ratio of the Value added (constant 2005 US$) in Guyana in 1998 to that in 2001?
Keep it short and to the point. 0.94. What is the ratio of the Value added (constant 2005 US$) of Lebanon in 1998 to that in 2001?
Give a very brief answer. 0.97. What is the ratio of the Value added (constant 2005 US$) in Trinidad and Tobago in 1998 to that in 2001?
Your response must be concise. 0.81. What is the ratio of the Value added (constant 2005 US$) of Lower middle income in 1998 to that in 2002?
Give a very brief answer. 0.9. What is the ratio of the Value added (constant 2005 US$) of Guyana in 1998 to that in 2002?
Give a very brief answer. 0.91. What is the ratio of the Value added (constant 2005 US$) in Lebanon in 1998 to that in 2002?
Give a very brief answer. 0.94. What is the ratio of the Value added (constant 2005 US$) in Trinidad and Tobago in 1998 to that in 2002?
Offer a very short reply. 0.74. What is the ratio of the Value added (constant 2005 US$) of Lower middle income in 1999 to that in 2000?
Offer a very short reply. 0.99. What is the ratio of the Value added (constant 2005 US$) of Guyana in 1999 to that in 2000?
Provide a short and direct response. 1.1. What is the ratio of the Value added (constant 2005 US$) of Lebanon in 1999 to that in 2000?
Keep it short and to the point. 0.98. What is the ratio of the Value added (constant 2005 US$) in Trinidad and Tobago in 1999 to that in 2000?
Ensure brevity in your answer.  1.02. What is the ratio of the Value added (constant 2005 US$) of Lower middle income in 1999 to that in 2001?
Give a very brief answer. 0.94. What is the ratio of the Value added (constant 2005 US$) in Guyana in 1999 to that in 2001?
Your answer should be very brief. 1.06. What is the ratio of the Value added (constant 2005 US$) of Lebanon in 1999 to that in 2001?
Your answer should be very brief. 1.01. What is the ratio of the Value added (constant 2005 US$) in Trinidad and Tobago in 1999 to that in 2001?
Offer a very short reply. 0.94. What is the ratio of the Value added (constant 2005 US$) of Lower middle income in 1999 to that in 2002?
Give a very brief answer. 0.93. What is the ratio of the Value added (constant 2005 US$) of Guyana in 1999 to that in 2002?
Your answer should be very brief. 1.03. What is the ratio of the Value added (constant 2005 US$) of Lebanon in 1999 to that in 2002?
Provide a short and direct response. 0.98. What is the ratio of the Value added (constant 2005 US$) in Trinidad and Tobago in 1999 to that in 2002?
Make the answer very short. 0.87. What is the ratio of the Value added (constant 2005 US$) in Lower middle income in 2000 to that in 2001?
Offer a terse response. 0.96. What is the ratio of the Value added (constant 2005 US$) in Guyana in 2000 to that in 2001?
Ensure brevity in your answer.  0.97. What is the ratio of the Value added (constant 2005 US$) in Lebanon in 2000 to that in 2001?
Make the answer very short. 1.03. What is the ratio of the Value added (constant 2005 US$) in Trinidad and Tobago in 2000 to that in 2001?
Ensure brevity in your answer.  0.92. What is the ratio of the Value added (constant 2005 US$) in Lower middle income in 2000 to that in 2002?
Your response must be concise. 0.94. What is the ratio of the Value added (constant 2005 US$) of Guyana in 2000 to that in 2002?
Give a very brief answer. 0.93. What is the ratio of the Value added (constant 2005 US$) of Lebanon in 2000 to that in 2002?
Your response must be concise. 1. What is the ratio of the Value added (constant 2005 US$) in Trinidad and Tobago in 2000 to that in 2002?
Provide a short and direct response. 0.85. What is the ratio of the Value added (constant 2005 US$) in Lower middle income in 2001 to that in 2002?
Offer a very short reply. 0.98. What is the ratio of the Value added (constant 2005 US$) of Guyana in 2001 to that in 2002?
Keep it short and to the point. 0.97. What is the ratio of the Value added (constant 2005 US$) in Lebanon in 2001 to that in 2002?
Offer a terse response. 0.97. What is the ratio of the Value added (constant 2005 US$) in Trinidad and Tobago in 2001 to that in 2002?
Provide a succinct answer. 0.92. What is the difference between the highest and the second highest Value added (constant 2005 US$) in Lower middle income?
Make the answer very short. 5.49e+09. What is the difference between the highest and the second highest Value added (constant 2005 US$) in Guyana?
Ensure brevity in your answer.  7.50e+06. What is the difference between the highest and the second highest Value added (constant 2005 US$) in Lebanon?
Offer a terse response. 1.34e+06. What is the difference between the highest and the second highest Value added (constant 2005 US$) in Trinidad and Tobago?
Provide a short and direct response. 1.18e+07. What is the difference between the highest and the lowest Value added (constant 2005 US$) in Lower middle income?
Ensure brevity in your answer.  6.20e+1. What is the difference between the highest and the lowest Value added (constant 2005 US$) in Guyana?
Your answer should be compact. 4.24e+07. What is the difference between the highest and the lowest Value added (constant 2005 US$) in Lebanon?
Keep it short and to the point. 9.06e+07. What is the difference between the highest and the lowest Value added (constant 2005 US$) of Trinidad and Tobago?
Provide a succinct answer. 3.83e+07. 